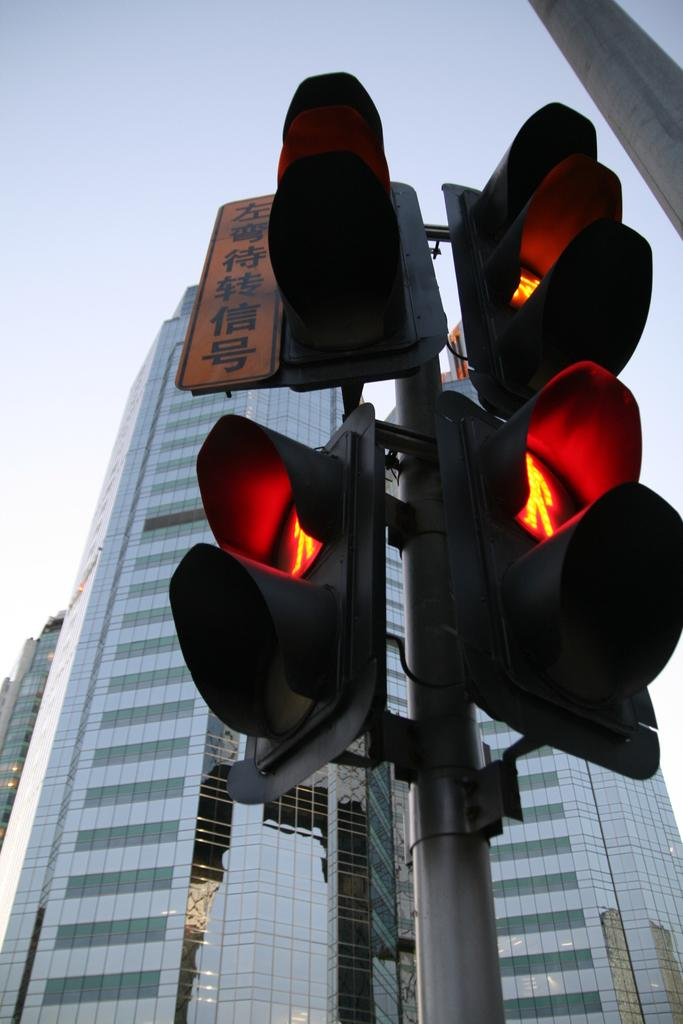What type of infrastructure is present in the image? There are traffic signals and poles in the image. What else can be seen in the image besides infrastructure? There are buildings and a board in the image. What is visible in the background of the image? The sky is visible in the background of the image. How many kittens are playing with the ring on the board in the image? There are no kittens or rings present in the image. What type of discovery was made at the location depicted in the image? The image does not depict any discovery or event; it simply shows traffic signals, poles, buildings, a board, and the sky. 